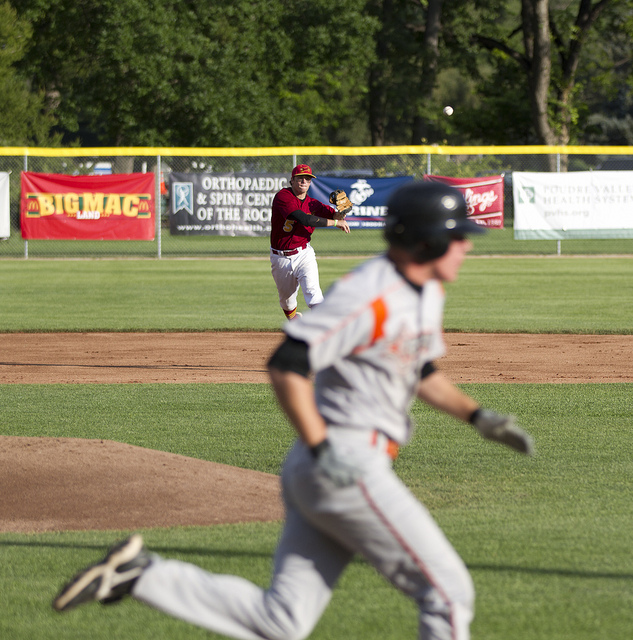<image>What food company is represented? I'm not sure which food company is represented, but it could be McDonald's. What food company is represented? I don't know what food company is represented. It could be McDonald's. 